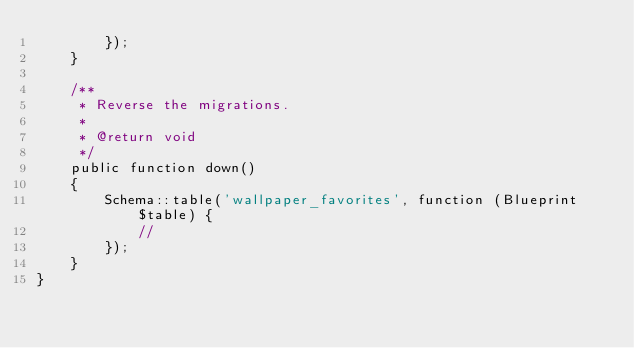Convert code to text. <code><loc_0><loc_0><loc_500><loc_500><_PHP_>        });
    }

    /**
     * Reverse the migrations.
     *
     * @return void
     */
    public function down()
    {
        Schema::table('wallpaper_favorites', function (Blueprint $table) {
            //
        });
    }
}
</code> 